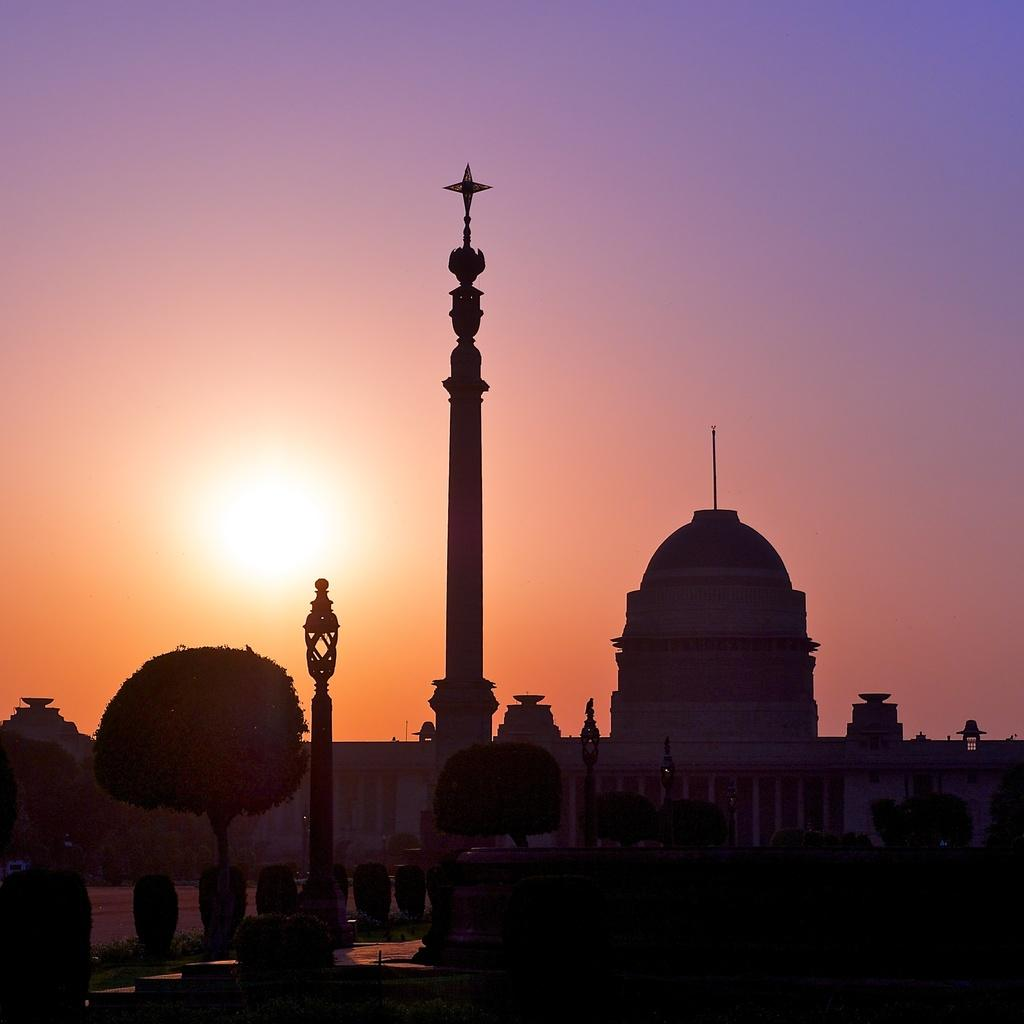What type of building is depicted in the image? The image appears to depict a palace. Are there any specific features of the palace that can be seen in the image? Yes, there is a tower in the image. What type of vegetation is visible in the image? Trees and small bushes are present in the image. What is the purpose of the light pole in the image? The light pole in the image is likely used for illuminating the area. What type of sheet is draped over the palace in the image? There is no sheet draped over the palace in the image; it is a solid structure. 